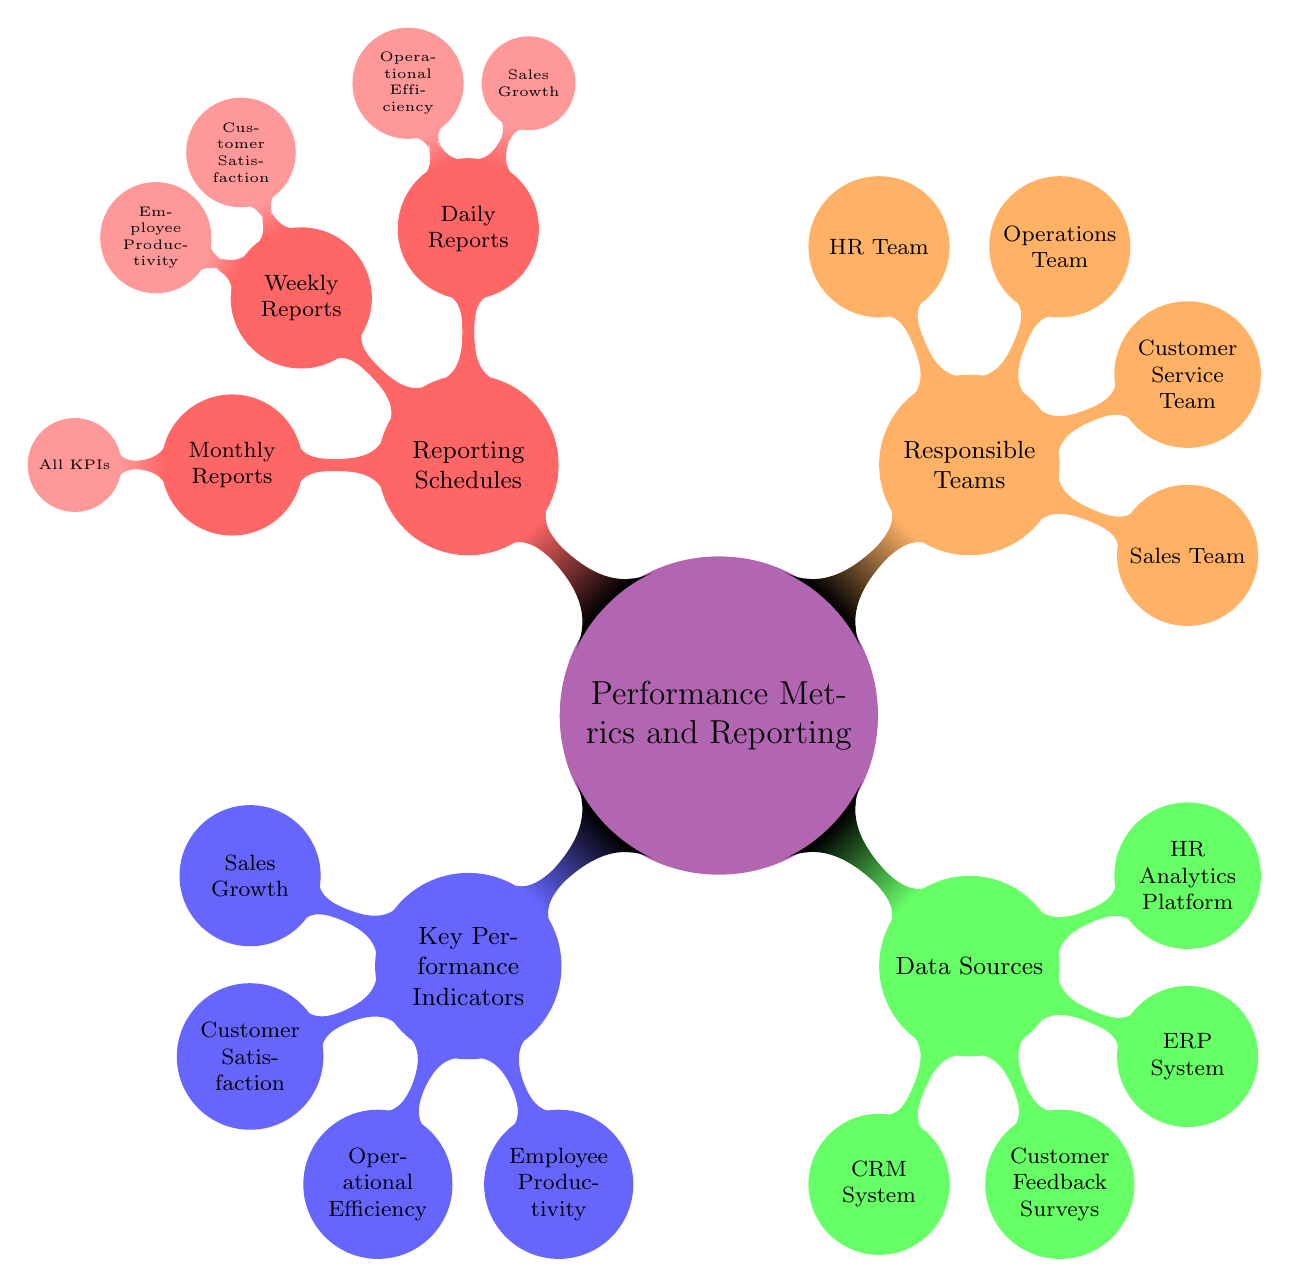What are the four key performance indicators listed? The diagram depicts four main child nodes under the "Key Performance Indicators" section, which are Sales Growth, Customer Satisfaction, Operational Efficiency, and Employee Productivity.
Answer: Sales Growth, Customer Satisfaction, Operational Efficiency, Employee Productivity How many teams are responsible for performance metrics? The "Responsible Teams" section of the diagram contains four nodes, each representing a different team: Sales Team, Customer Service Team, Operations Team, and HR Team.
Answer: Four Which team is responsible for the Sales Growth daily report? Under the "Daily Reports" subsection of "Reporting Schedules," the Sales Team is indicated as responsible for the Sales Growth report.
Answer: Sales Team What is the frequency of the Customer Satisfaction report? The diagram indicates that the Customer Satisfaction report falls under the "Weekly Reports" section of the "Reporting Schedules."
Answer: Weekly Which two metrics are included under Daily Reports? By examining the "Daily Reports" section, we see two metrics listed: Sales Growth and Operational Efficiency, both of which are reported daily.
Answer: Sales Growth, Operational Efficiency Which data source might be used for Employee Productivity metrics? The "Data Sources" section includes the HR Analytics Platform, which directly relates to tracking Employee Productivity as it deals with human resources data.
Answer: HR Analytics Platform How are monthly reports structured in terms of KPIs? The "Monthly Reports" section lists all key performance indicators: Sales Growth, Customer Satisfaction, Operational Efficiency, and Employee Productivity, indicating that all are included in this report.
Answer: All KPIs Which team handles Customer Satisfaction metrics? The "Customer Service Team" is clearly indicated in the "Responsible Teams" section and is also responsible for the Customer Satisfaction metric, as shown in the reporting schedules.
Answer: Customer Service Team What color represents the Reporting Schedules section? Referring to the diagram, the "Reporting Schedules" section is represented with the color red, which is the node color designated for this category.
Answer: Red 